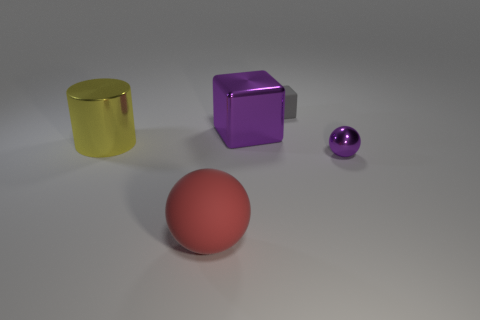Is there anything else that has the same shape as the big red thing?
Offer a very short reply. Yes. How many big yellow rubber objects are there?
Your answer should be very brief. 0. How many green objects are either rubber things or tiny balls?
Provide a short and direct response. 0. Are the large object that is in front of the yellow metal cylinder and the tiny gray cube made of the same material?
Offer a terse response. Yes. How many other objects are there of the same material as the red object?
Ensure brevity in your answer.  1. What is the material of the big yellow cylinder?
Give a very brief answer. Metal. What is the size of the thing that is in front of the small ball?
Provide a succinct answer. Large. There is a purple metal thing in front of the large yellow metal object; what number of tiny purple metallic things are behind it?
Provide a short and direct response. 0. Does the large thing right of the red object have the same shape as the matte object on the right side of the big shiny block?
Offer a terse response. Yes. What number of metallic things are to the left of the tiny metal sphere and in front of the big purple metallic object?
Offer a terse response. 1. 